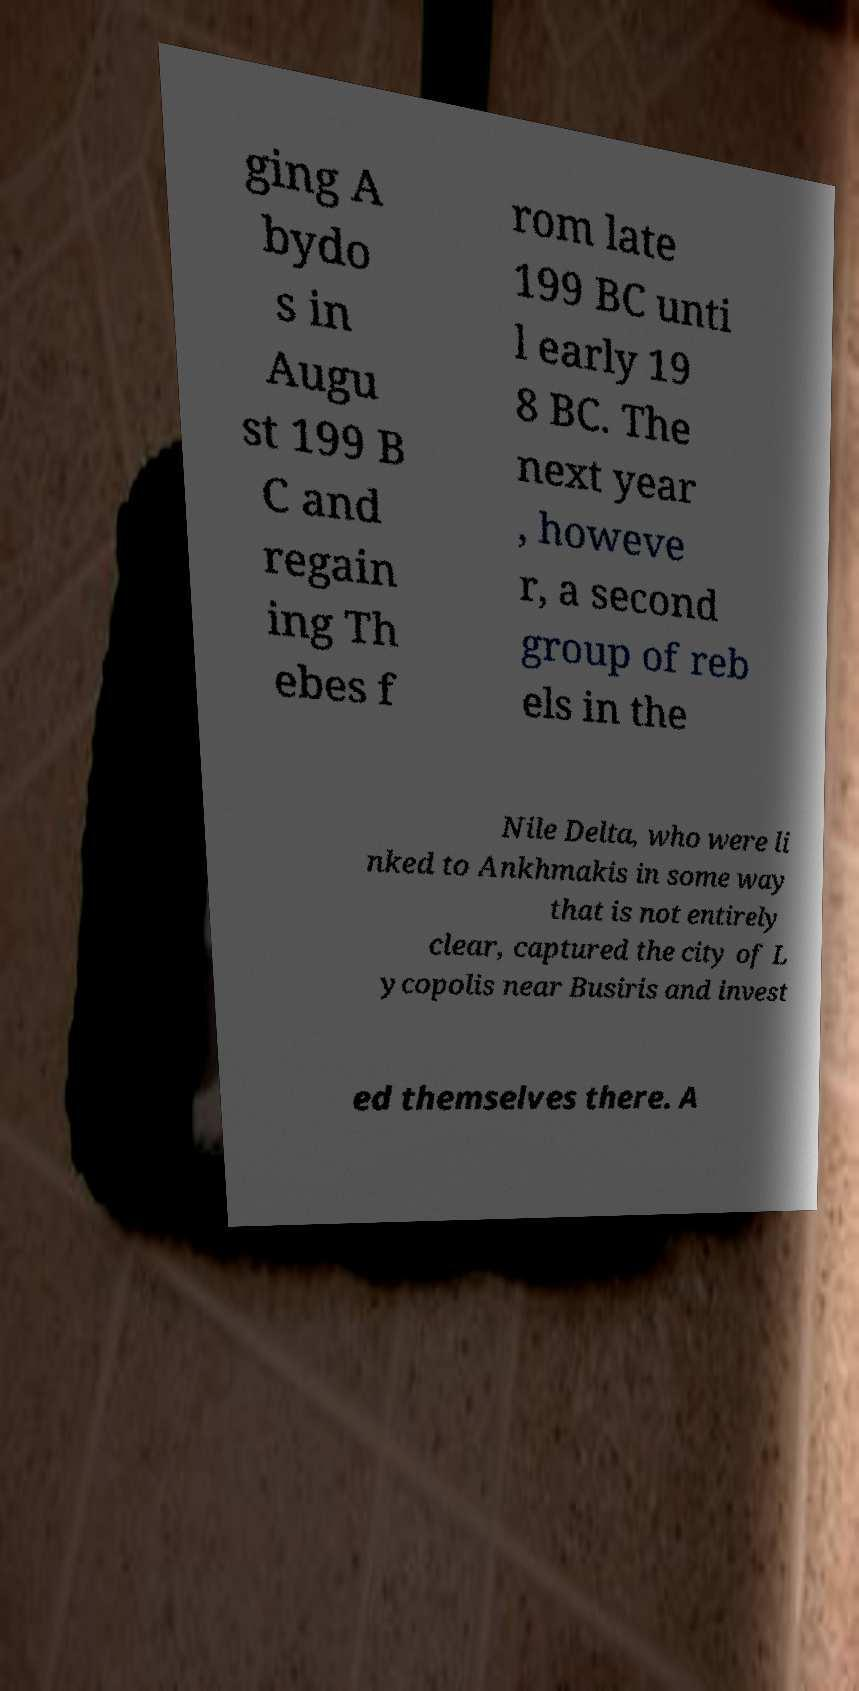There's text embedded in this image that I need extracted. Can you transcribe it verbatim? ging A bydo s in Augu st 199 B C and regain ing Th ebes f rom late 199 BC unti l early 19 8 BC. The next year , howeve r, a second group of reb els in the Nile Delta, who were li nked to Ankhmakis in some way that is not entirely clear, captured the city of L ycopolis near Busiris and invest ed themselves there. A 